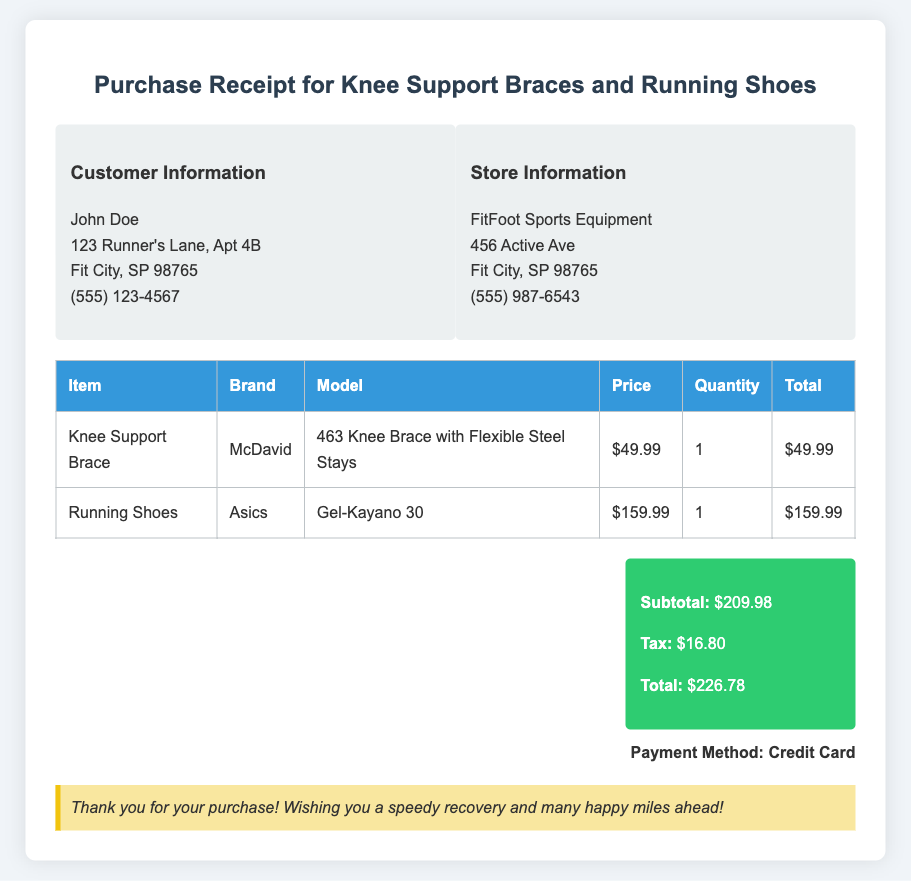What is the name of the customer? The customer's name is listed in the document under customer information.
Answer: John Doe What is the total amount paid? The total amount paid is shown in the summary section of the receipt.
Answer: $226.78 What brand is the knee support brace? The brand of the knee support brace is specified in the item list of the document.
Answer: McDavid How much are the running shoes? The price of the running shoes is provided in the table under the price column.
Answer: $159.99 What is the subtotal before tax? The subtotal is calculated and presented in the summary section of the receipt.
Answer: $209.98 What is the model of the running shoes? The model of the running shoes is mentioned in the table detailing the items purchased.
Answer: Gel-Kayano 30 How many items were purchased in total? The total quantity of items purchased can be derived from the itemized list provided in the document.
Answer: 2 What payment method was used? The payment method is indicated at the bottom of the document.
Answer: Credit Card Where was the purchase made? The store information reveals where the purchase took place.
Answer: FitFoot Sports Equipment 